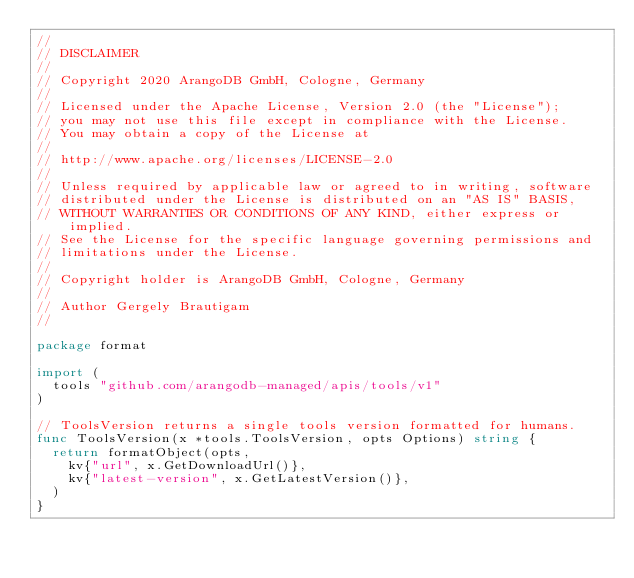<code> <loc_0><loc_0><loc_500><loc_500><_Go_>//
// DISCLAIMER
//
// Copyright 2020 ArangoDB GmbH, Cologne, Germany
//
// Licensed under the Apache License, Version 2.0 (the "License");
// you may not use this file except in compliance with the License.
// You may obtain a copy of the License at
//
// http://www.apache.org/licenses/LICENSE-2.0
//
// Unless required by applicable law or agreed to in writing, software
// distributed under the License is distributed on an "AS IS" BASIS,
// WITHOUT WARRANTIES OR CONDITIONS OF ANY KIND, either express or implied.
// See the License for the specific language governing permissions and
// limitations under the License.
//
// Copyright holder is ArangoDB GmbH, Cologne, Germany
//
// Author Gergely Brautigam
//

package format

import (
	tools "github.com/arangodb-managed/apis/tools/v1"
)

// ToolsVersion returns a single tools version formatted for humans.
func ToolsVersion(x *tools.ToolsVersion, opts Options) string {
	return formatObject(opts,
		kv{"url", x.GetDownloadUrl()},
		kv{"latest-version", x.GetLatestVersion()},
	)
}
</code> 